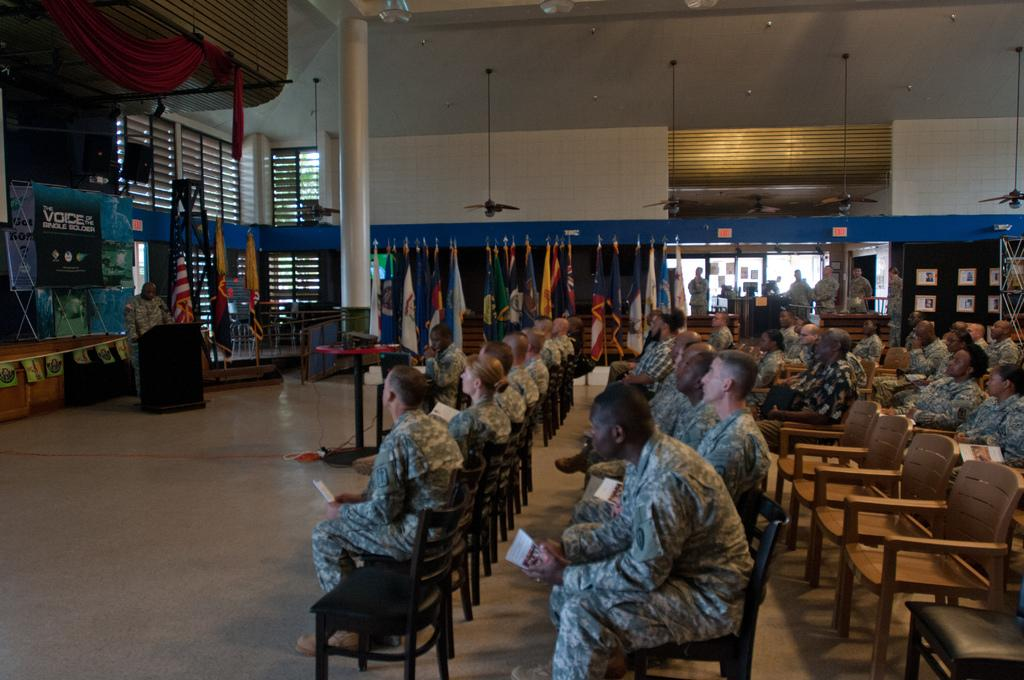What are the soldiers in the image doing? The soldiers in the image are sitting on chairs. What are the soldiers holding in their hands? A: The soldiers are holding papers. What can be seen in the background of the image? There are flags of other countries in the image. What might be used for cooling in the image? There are fans visible in the image. What is present on the walls in the image? There are photo frames on the walls. What type of window can be seen in the image? There is no window present in the image. What color is the branch that the soldier is holding in the image? There is no branch present in the image; the soldiers are holding papers. 